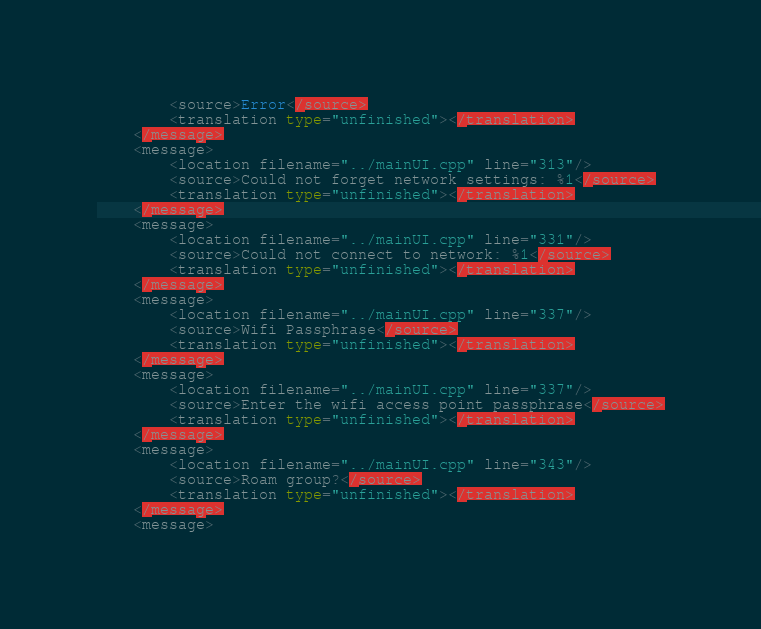<code> <loc_0><loc_0><loc_500><loc_500><_TypeScript_>        <source>Error</source>
        <translation type="unfinished"></translation>
    </message>
    <message>
        <location filename="../mainUI.cpp" line="313"/>
        <source>Could not forget network settings: %1</source>
        <translation type="unfinished"></translation>
    </message>
    <message>
        <location filename="../mainUI.cpp" line="331"/>
        <source>Could not connect to network: %1</source>
        <translation type="unfinished"></translation>
    </message>
    <message>
        <location filename="../mainUI.cpp" line="337"/>
        <source>Wifi Passphrase</source>
        <translation type="unfinished"></translation>
    </message>
    <message>
        <location filename="../mainUI.cpp" line="337"/>
        <source>Enter the wifi access point passphrase</source>
        <translation type="unfinished"></translation>
    </message>
    <message>
        <location filename="../mainUI.cpp" line="343"/>
        <source>Roam group?</source>
        <translation type="unfinished"></translation>
    </message>
    <message></code> 